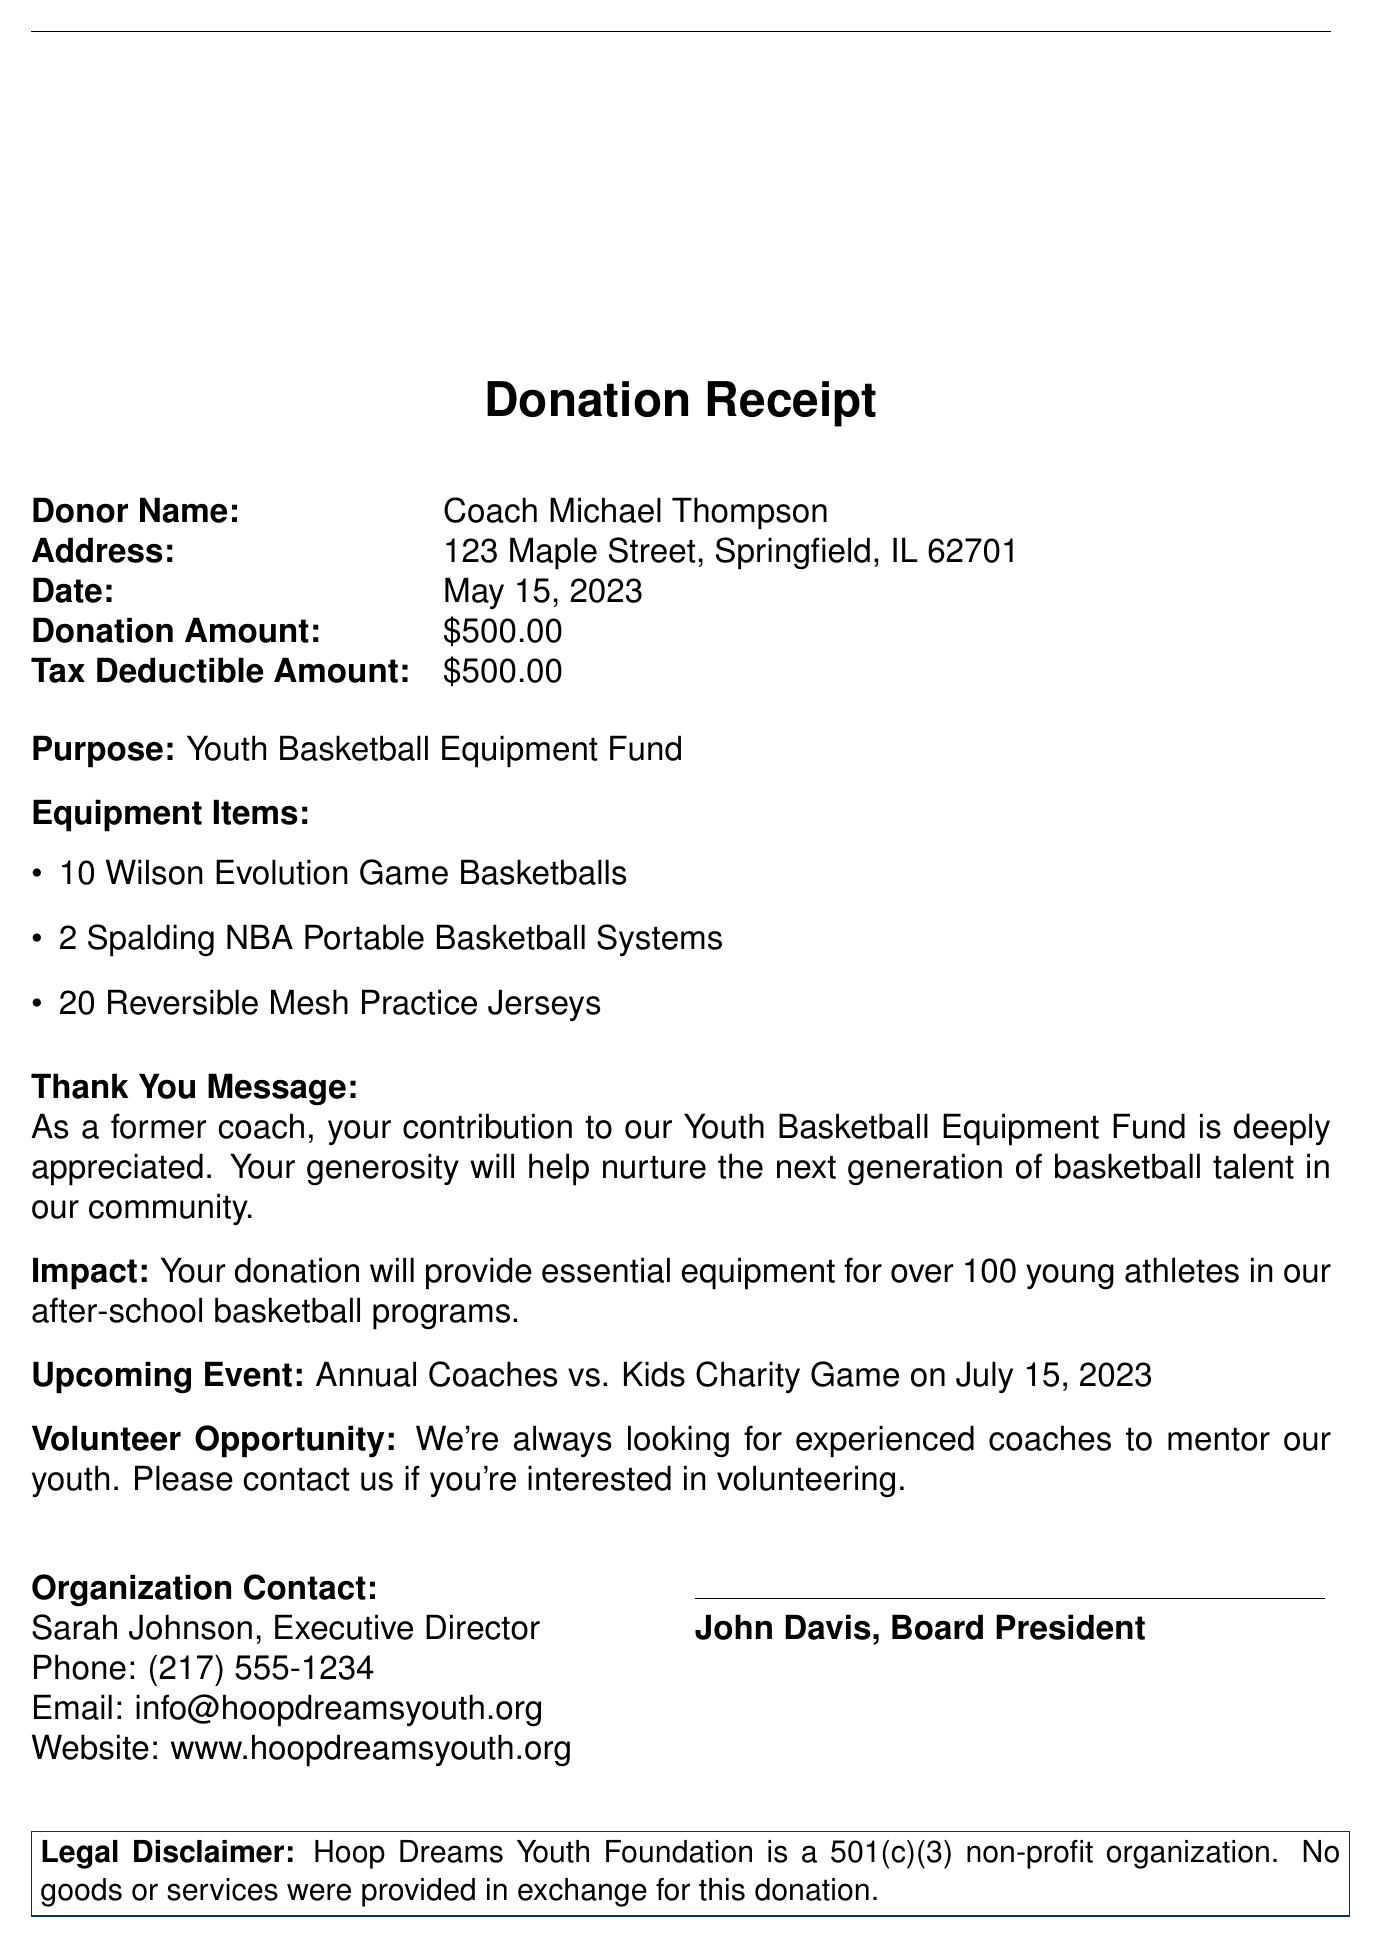What is the name of the organization? The name of the organization is listed at the top of the document as "Hoop Dreams Youth Foundation."
Answer: Hoop Dreams Youth Foundation Who is the donor? The donor's name is stated in the document as "Coach Michael Thompson."
Answer: Coach Michael Thompson What was the donation amount? The donation amount is specified in the document as "$500.00."
Answer: $500.00 What items are included in the equipment donation? The document lists specific equipment items donated, including basketballs, systems, and jerseys.
Answer: 10 Wilson Evolution Game Basketballs, 2 Spalding NBA Portable Basketball Systems, 20 Reversible Mesh Practice Jerseys What is the purpose of the donation? The document clearly states that the purpose of the donation is for the "Youth Basketball Equipment Fund."
Answer: Youth Basketball Equipment Fund What is the date of the donation? The date of the donation is recorded in the document as "May 15, 2023."
Answer: May 15, 2023 What is the tax-deductible portion of the donation? The document indicates the tax-deductible amount, which aligns with the total donation.
Answer: $500.00 How many young athletes will benefit from the donation? The impact statement in the document mentions that the donation will assist over "100 young athletes."
Answer: 100 Who signed the receipt? The document includes a signature from "John Davis, Board President," indicating approval and acknowledgment of the donation.
Answer: John Davis, Board President What is the upcoming event mentioned in the document? The document details an upcoming charity event titled "Annual Coaches vs. Kids Charity Game on July 15, 2023."
Answer: Annual Coaches vs. Kids Charity Game on July 15, 2023 